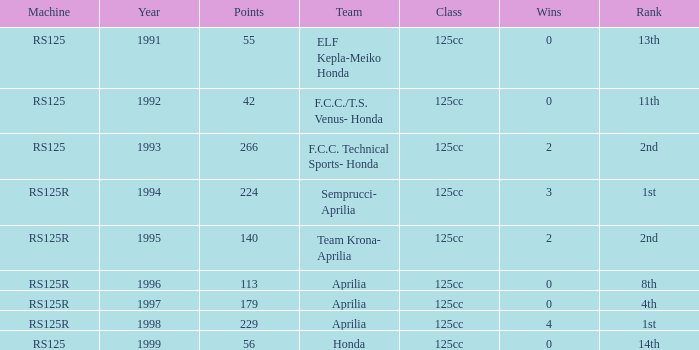Give me the full table as a dictionary. {'header': ['Machine', 'Year', 'Points', 'Team', 'Class', 'Wins', 'Rank'], 'rows': [['RS125', '1991', '55', 'ELF Kepla-Meiko Honda', '125cc', '0', '13th'], ['RS125', '1992', '42', 'F.C.C./T.S. Venus- Honda', '125cc', '0', '11th'], ['RS125', '1993', '266', 'F.C.C. Technical Sports- Honda', '125cc', '2', '2nd'], ['RS125R', '1994', '224', 'Semprucci- Aprilia', '125cc', '3', '1st'], ['RS125R', '1995', '140', 'Team Krona- Aprilia', '125cc', '2', '2nd'], ['RS125R', '1996', '113', 'Aprilia', '125cc', '0', '8th'], ['RS125R', '1997', '179', 'Aprilia', '125cc', '0', '4th'], ['RS125R', '1998', '229', 'Aprilia', '125cc', '4', '1st'], ['RS125', '1999', '56', 'Honda', '125cc', '0', '14th']]} Which team had a year beyond 1995, machine of rs125r, and ranked 1st? Aprilia. 